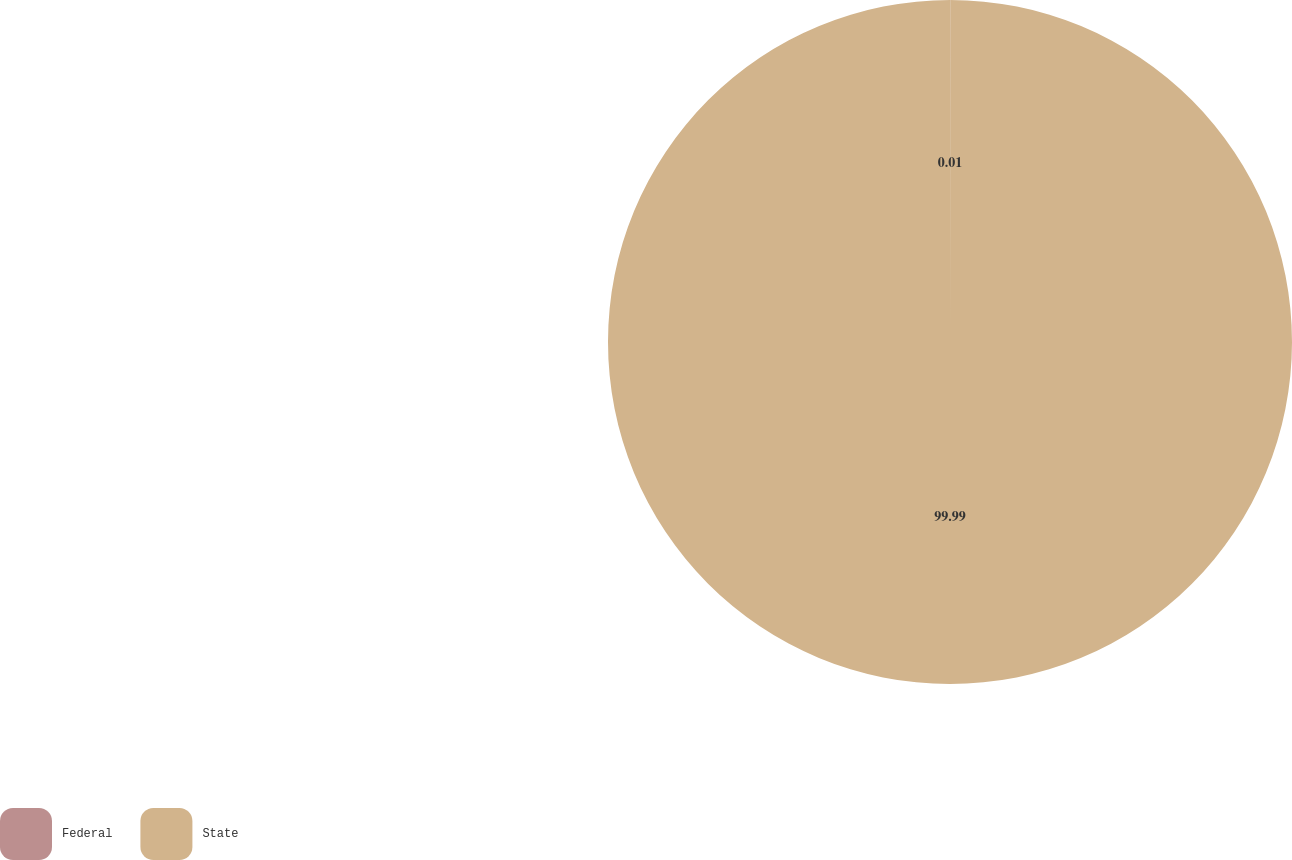Convert chart to OTSL. <chart><loc_0><loc_0><loc_500><loc_500><pie_chart><fcel>Federal<fcel>State<nl><fcel>0.01%<fcel>99.99%<nl></chart> 